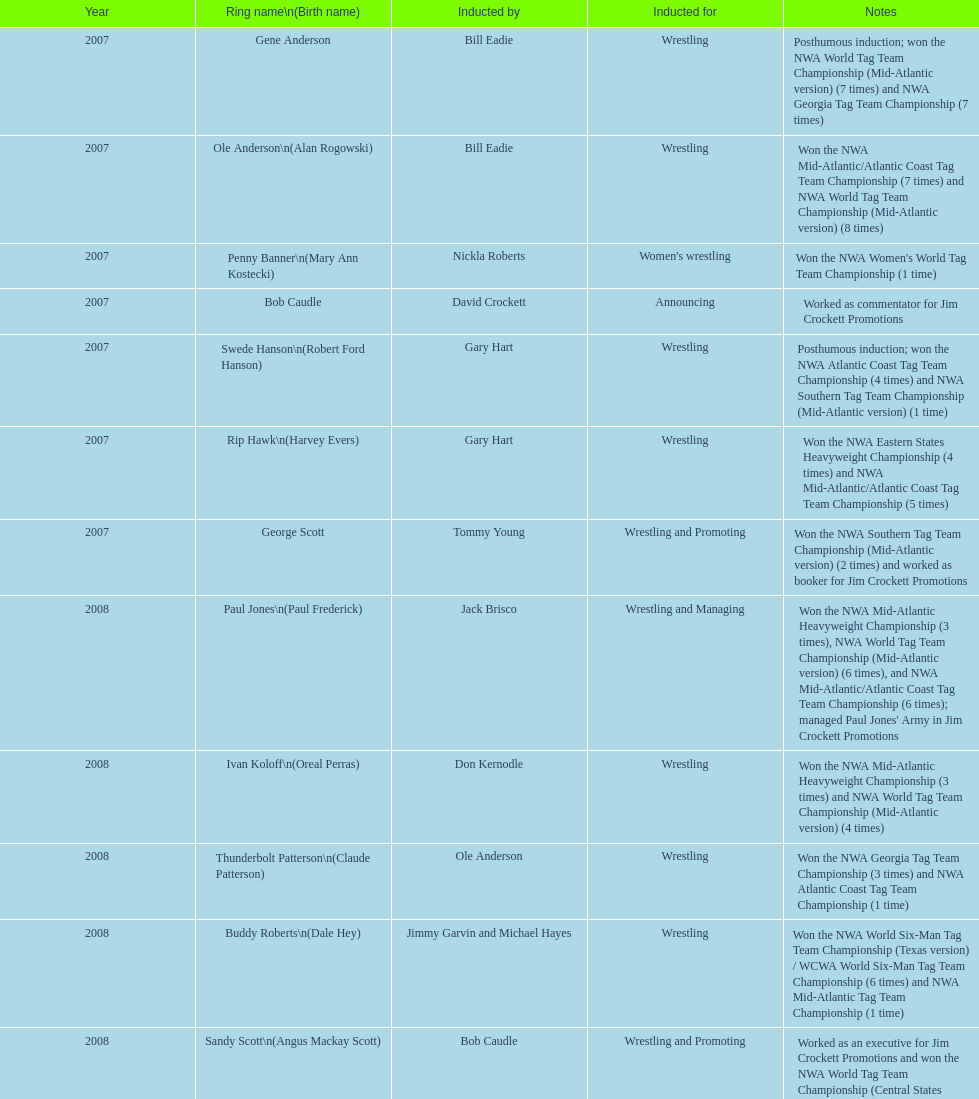How many members were introduced for declaring? 2. 